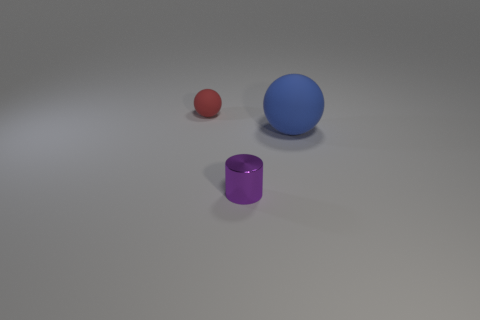How might you describe the atmosphere or mood of this scene? The scene has a minimalist and clean atmosphere, emanating a sense of calm and order. The neutral background and the simple arrangement of the objects create a serene and almost contemplative mood. 